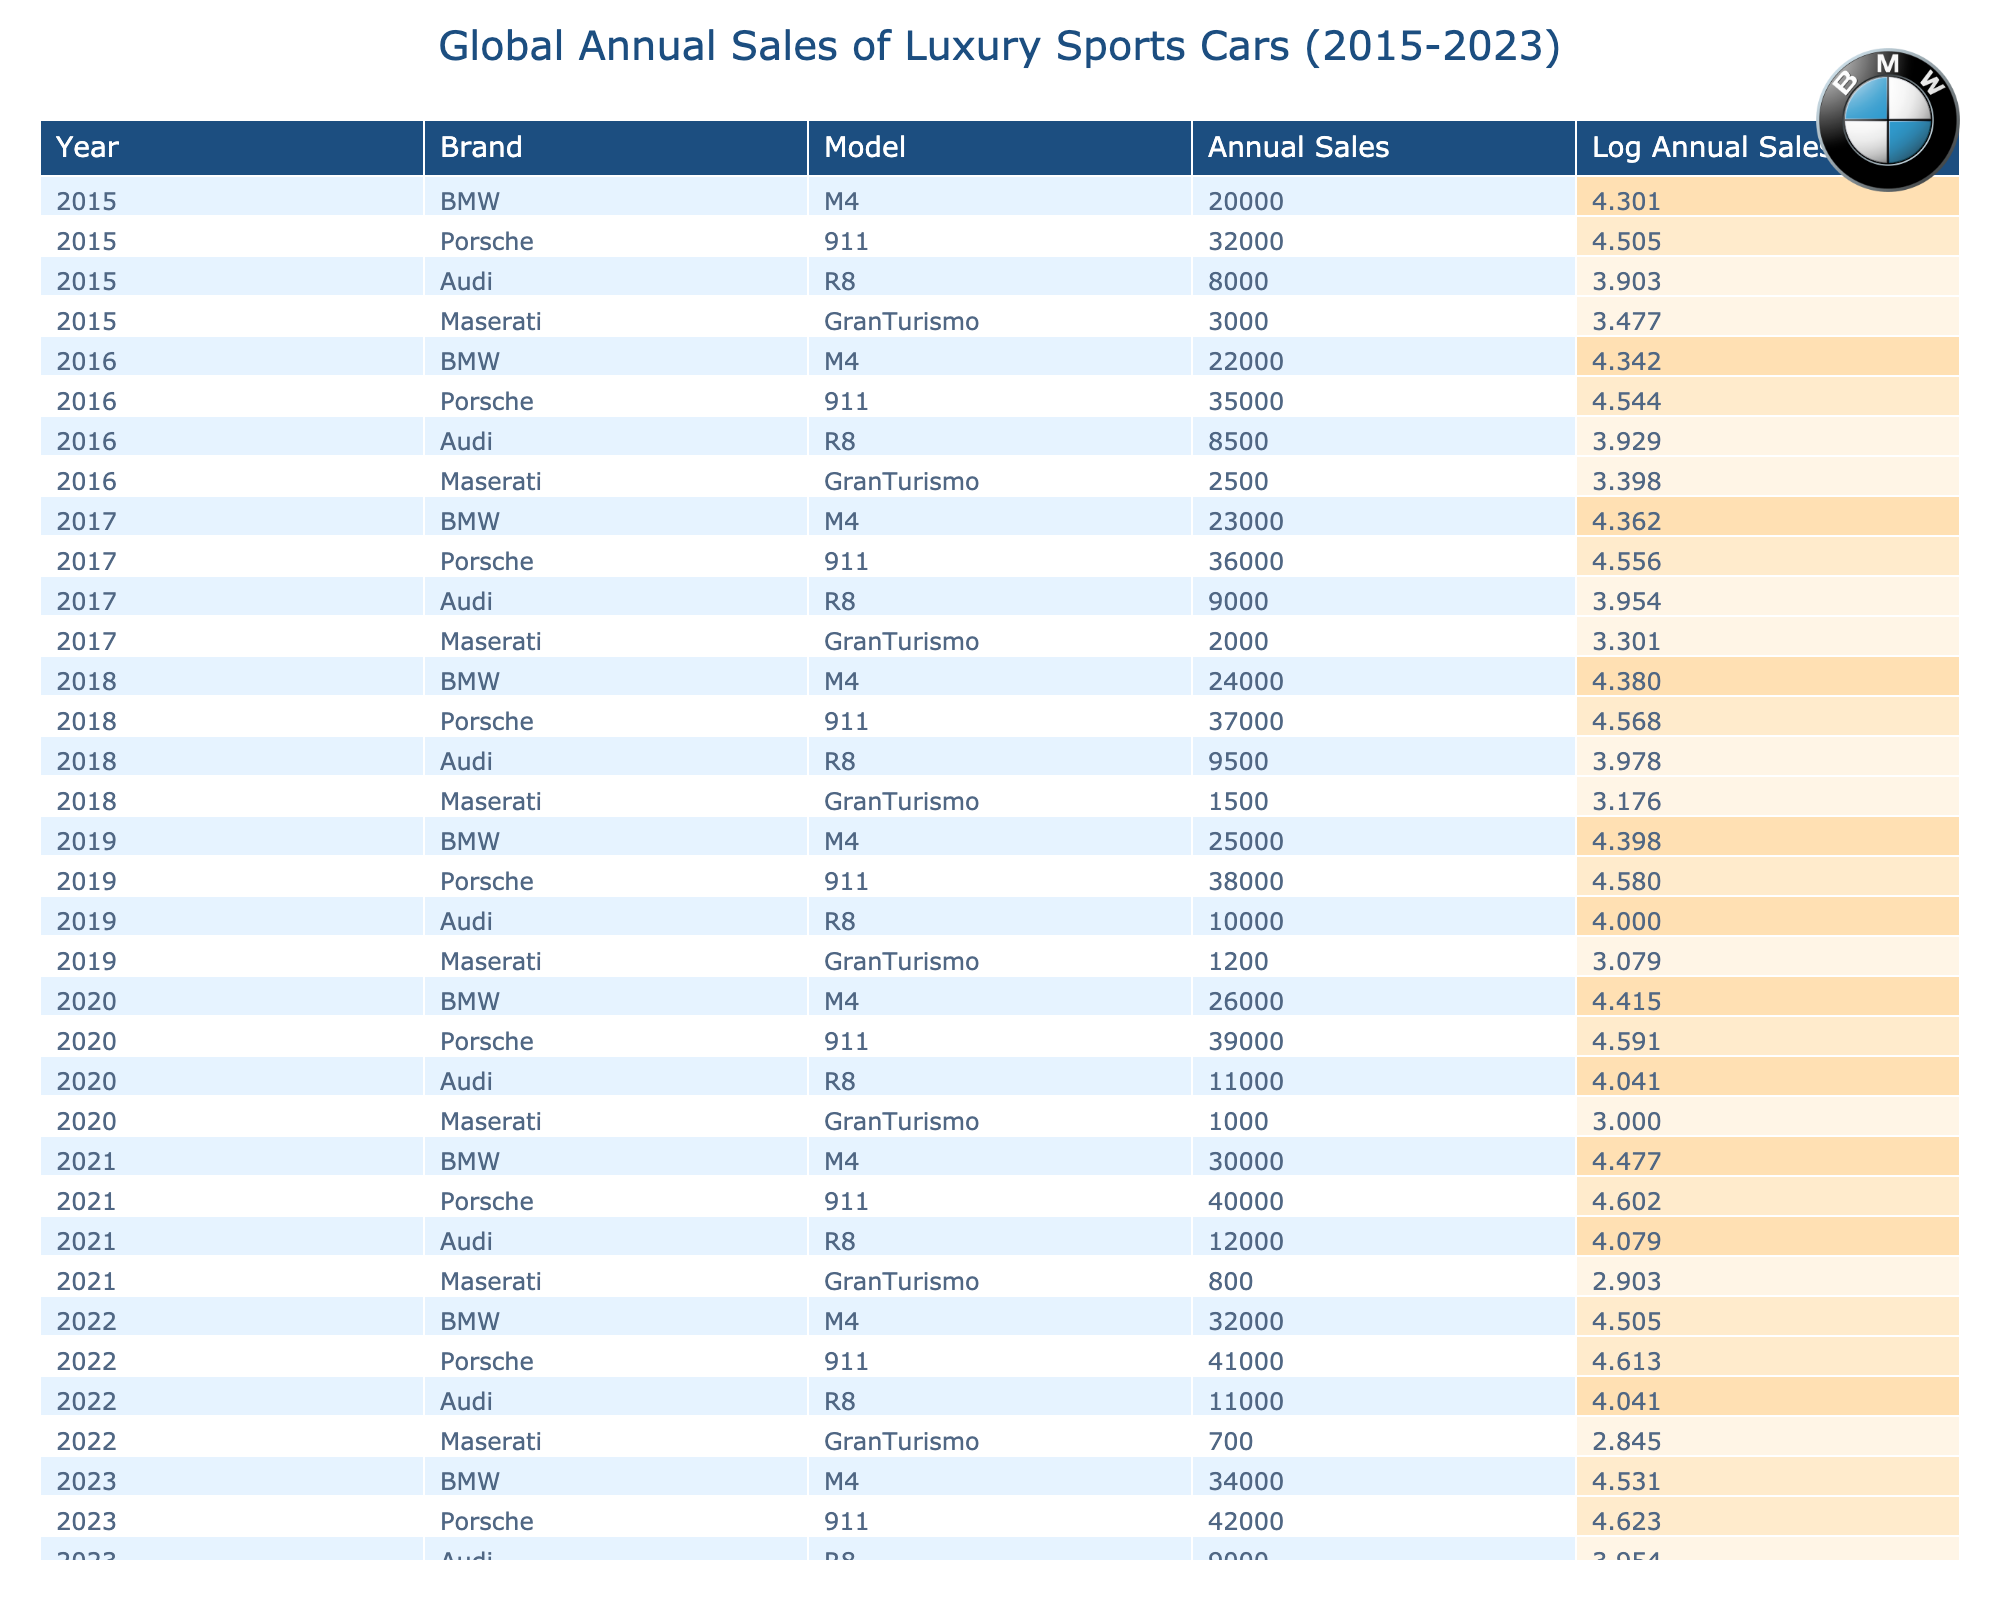What was the annual sales figure for the BMW M4 in 2022? In the table, I look for the row where the brand is BMW and the model is M4 in the year 2022. The corresponding annual sales figure is 32,000.
Answer: 32,000 In which year did Porsche 911 have the highest annual sales? By examining the table, I see that the sales figures for the Porsche 911 increase year by year until 2023, where it reaches 42,000, which is higher than all previous years.
Answer: 2023 What is the total annual sales of the Maserati GranTurismo from 2015 to 2023? I add up the annual sales figures for the Maserati GranTurismo from each year: 3,000 + 2,500 + 2,000 + 1,500 + 1,200 + 1,000 + 800 + 700 + 650 = 14,600.
Answer: 14,600 Is the annual sales figure for the Audi R8 in 2019 greater than in 2020? I check the annual sales figures for Audi R8 in both years. In 2019, it's 10,000 and in 2020, it's 11,000. Since 10,000 is less than 11,000, the statement is false.
Answer: No What is the average annual sales figure for the BMW M4 from 2015 to 2023? I calculate the average by summing the annual sales figures of BMW M4 for all years: 20,000 + 22,000 + 23,000 + 24,000 + 25,000 + 26,000 + 30,000 + 32,000 + 34,000 =  2 0 4 0 0 0, then divide by 9 (the number of years): 204,000 / 9 = 22,666.67.
Answer: 22,666.67 Which brand had the least annual sales in 2021? Looking at the table for the year 2021, I note the annual sales figures: BMW M4 (30,000), Porsche 911 (40,000), Audi R8 (12,000), and Maserati GranTurismo (800). Maserati GranTurismo has the lowest figure at 800.
Answer: Maserati How many more annual sales did the Porsche 911 have compared to the Audi R8 in 2020? I find the figures for both brands in 2020: Porsche 911 had 39,000, while Audi R8 had 11,000. I calculate the difference: 39,000 - 11,000 = 28,000.
Answer: 28,000 Did the Audi R8 experience any decline in annual sales over the years from 2015 to 2023? Checking the sales figures year by year for Audi R8 (8,000, 8,500, 9,000, 9,500, 10,000, 11,000, 12,000, 11,000, 9,000), I observe that sales generally increased until 2021, but there is a decline in both 2022 and 2023. Therefore, it did experience a decline in the last two years.
Answer: Yes 